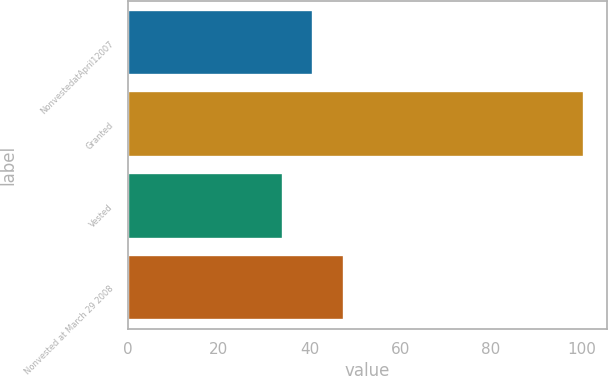Convert chart. <chart><loc_0><loc_0><loc_500><loc_500><bar_chart><fcel>NonvestedatApril12007<fcel>Granted<fcel>Vested<fcel>Nonvested at March 29 2008<nl><fcel>40.86<fcel>100.56<fcel>34.23<fcel>47.55<nl></chart> 